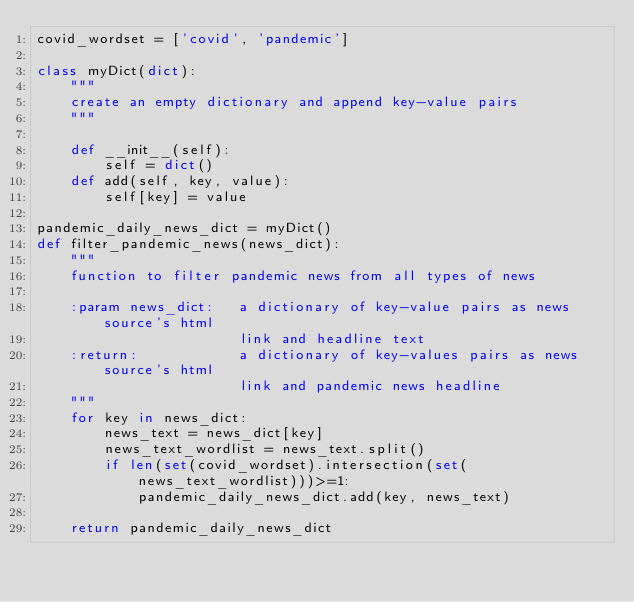Convert code to text. <code><loc_0><loc_0><loc_500><loc_500><_Python_>covid_wordset = ['covid', 'pandemic']

class myDict(dict):
    """
    create an empty dictionary and append key-value pairs
    """

    def __init__(self):
        self = dict()
    def add(self, key, value):
        self[key] = value

pandemic_daily_news_dict = myDict()
def filter_pandemic_news(news_dict):
    """
    function to filter pandemic news from all types of news

    :param news_dict:   a dictionary of key-value pairs as news source's html
                        link and headline text
    :return:            a dictionary of key-values pairs as news source's html
                        link and pandemic news headline
    """
    for key in news_dict:
        news_text = news_dict[key]
        news_text_wordlist = news_text.split()
        if len(set(covid_wordset).intersection(set(news_text_wordlist)))>=1:
            pandemic_daily_news_dict.add(key, news_text)

    return pandemic_daily_news_dict
</code> 